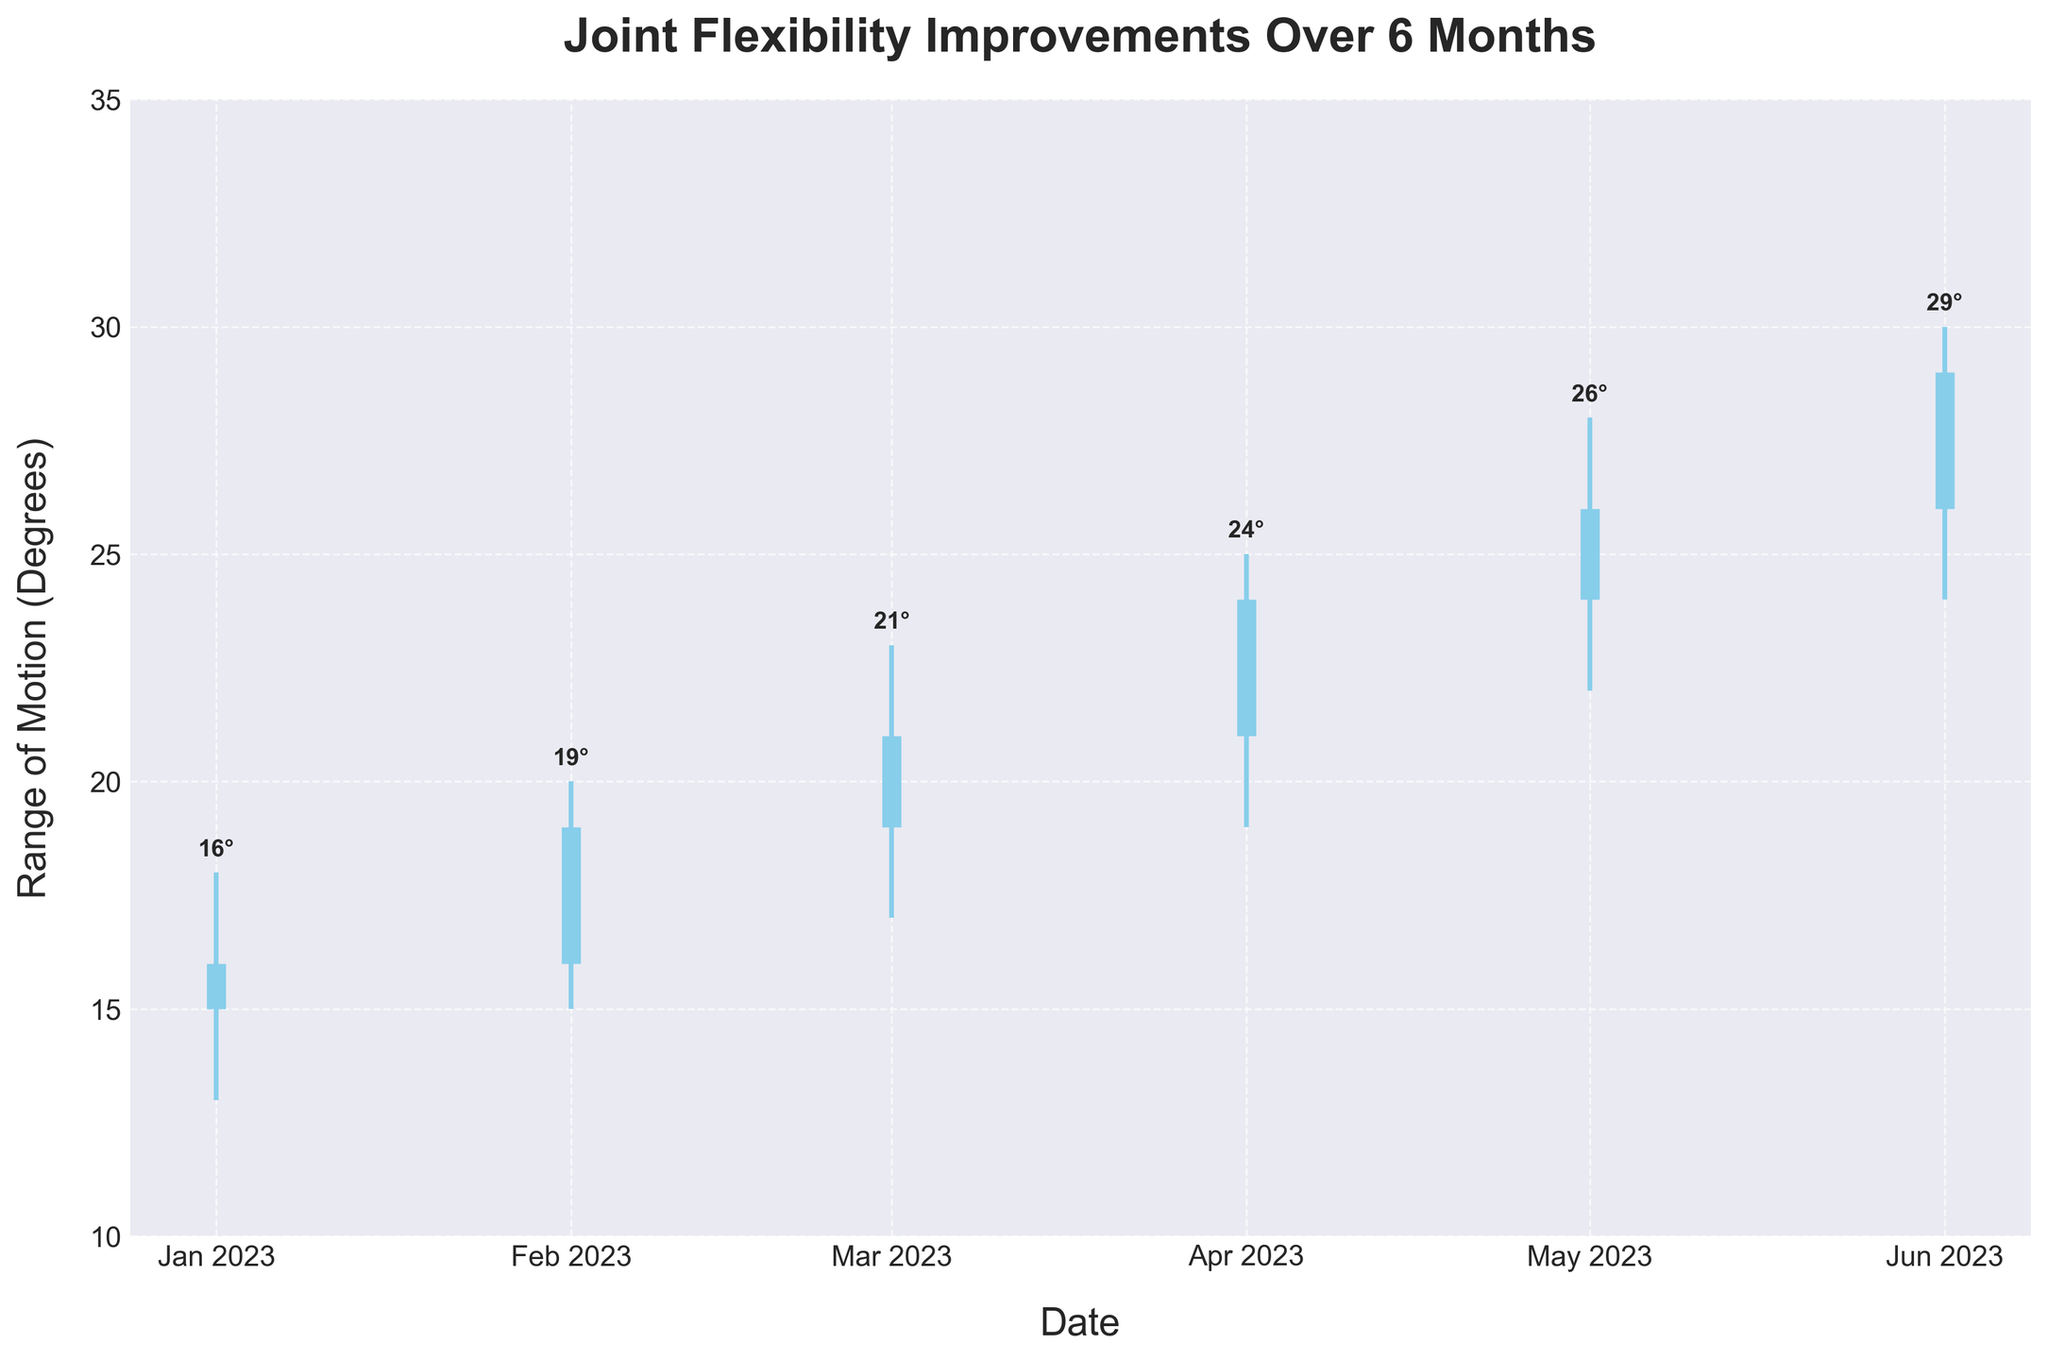what is the title of the figure? The title is clearly displayed at the top of the plot, reading "Joint Flexibility Improvements Over 6 Months".
Answer: "Joint Flexibility Improvements Over 6 Months" How many data points are represented in the figure? The figure shows six distinct data points, one for each month from January to June.
Answer: 6 What is the range of motion (degrees) in May? In May, the range of motion is represented by the high and low values which are 28 and 22 degrees respectively. The range is 28 - 22 = 6 degrees.
Answer: 6 Did the range of motion close higher or lower in February compared to January? In January, the close value is 16 degrees, and in February it is 19 degrees. 19 is higher than 16.
Answer: Higher What was the highest range of motion recorded in the 6-month period? The highest range of motion recorded appears in June, with the high value reaching 30 degrees.
Answer: 30 degrees What is the average closing joint flexion over the 6 months? The closing values for each month are 16, 19, 21, 24, 26, and 29 degrees. Sum these values and divide by the number of months: (16 + 19 + 21 + 24 + 26 + 29) / 6 = 22.5
Answer: 22.5 degrees Which month saw the smallest daily range of motion? The smallest daily range is observed when subtracting the lowest from the highest values: 
January: 18 - 13 = 5 
February: 20 - 15 = 5
March: 23 - 17 = 6
April: 25 - 19 = 6
May: 28 - 22 = 6
June: 30 - 24 = 6
Both January and February had the smallest daily range of 5 degrees.
Answer: January and February In what month did the joint flexibility close at its highest value? The highest closing value is seen in June, which is 29 degrees.
Answer: June Across the six months, how much did the closing value improve in total? Starting in January at 16 degrees and reaching 29 degrees in June, the improvement is calculated as 29 - 16.
Answer: 13 degrees 